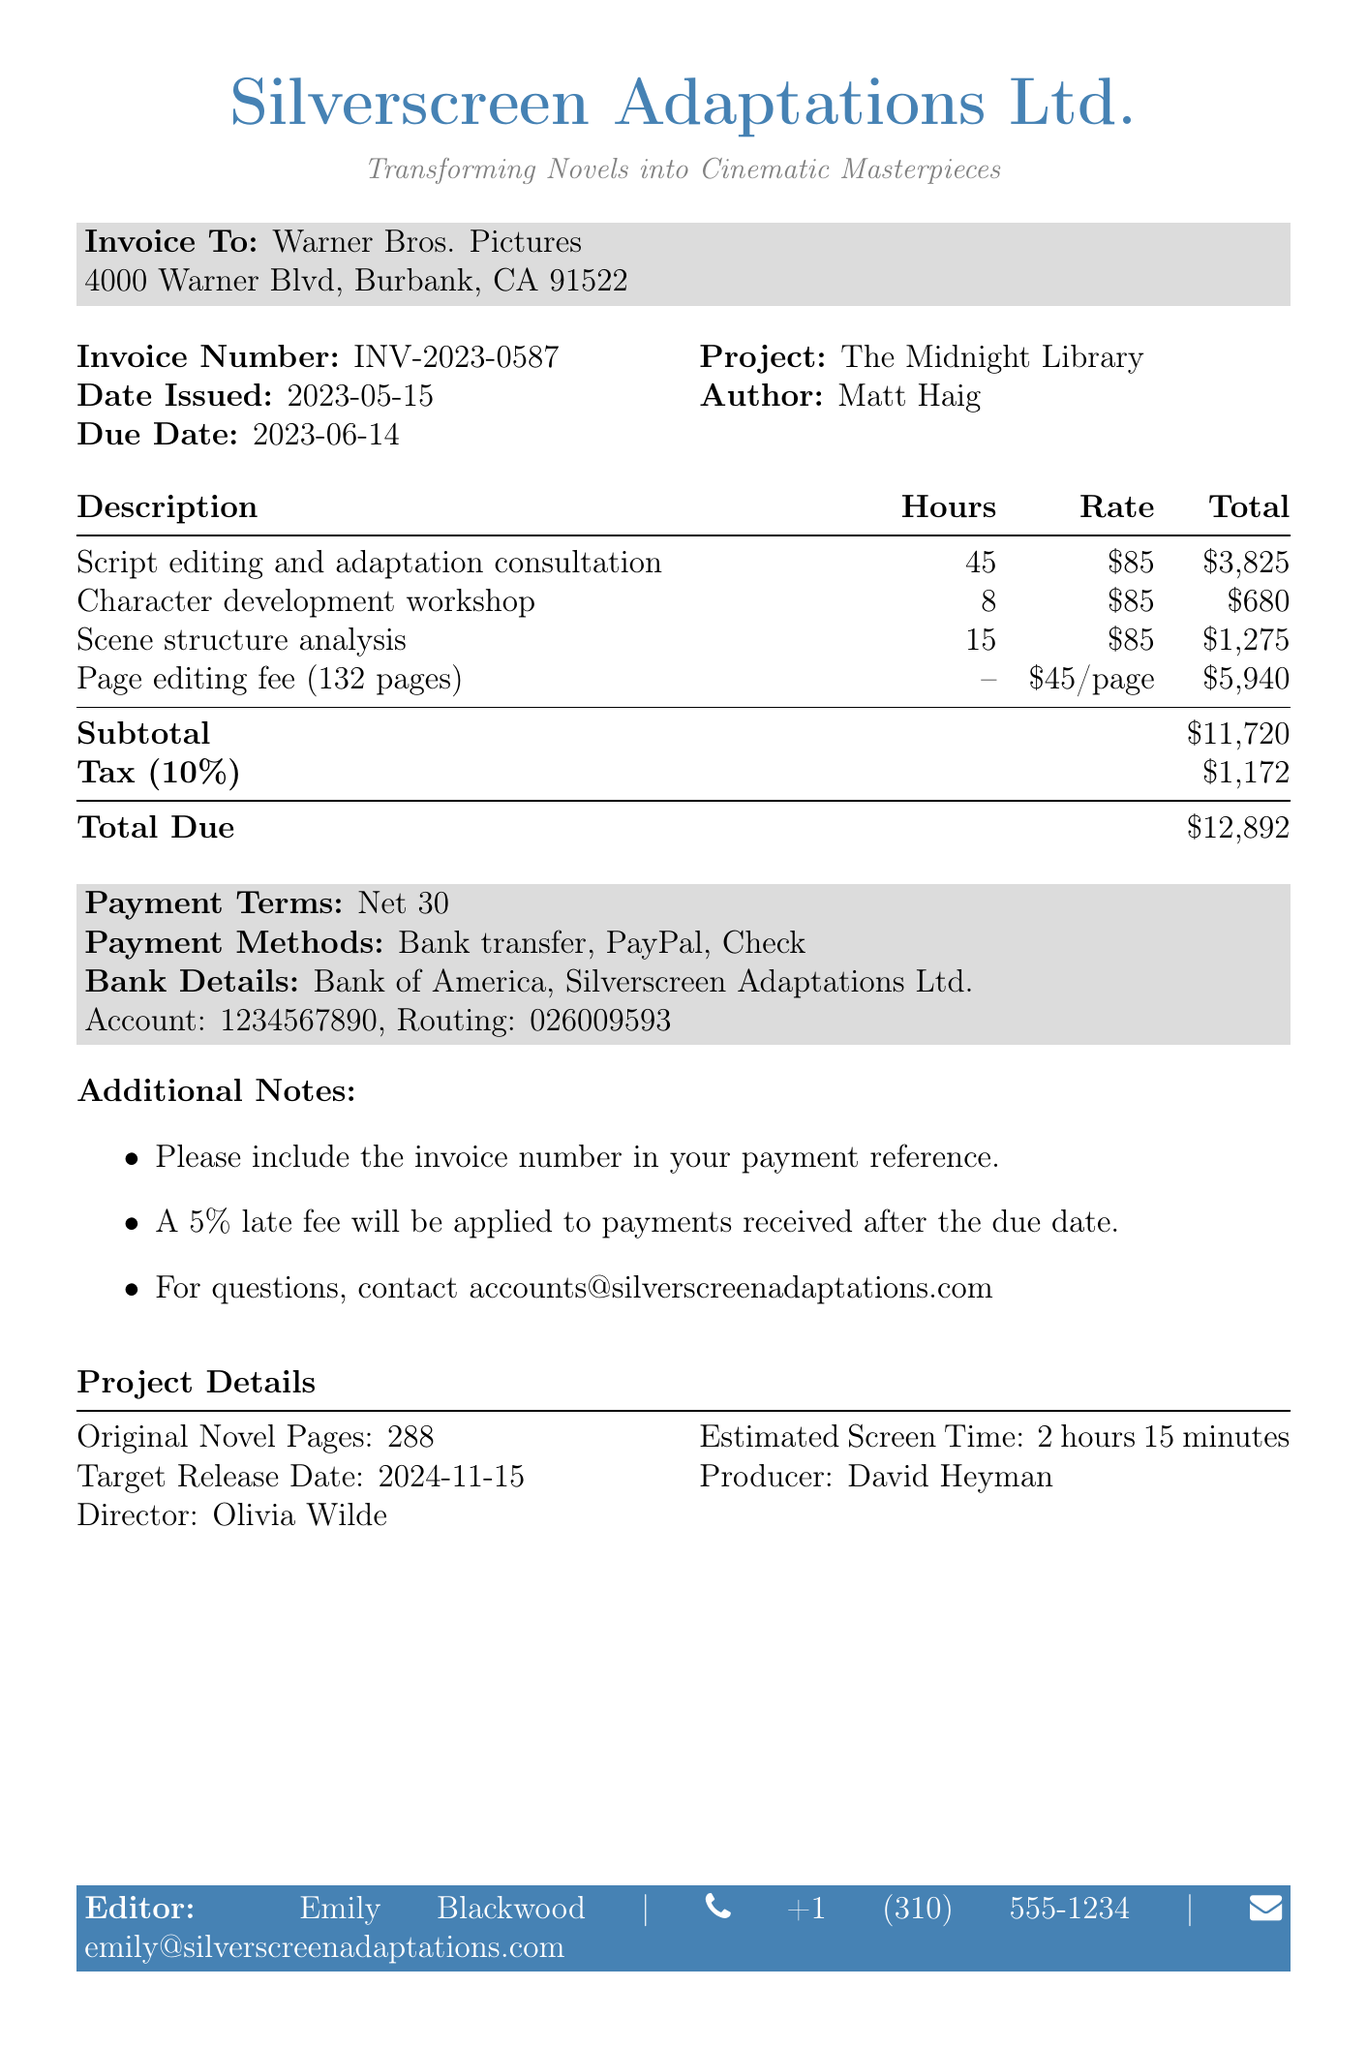What is the invoice number? The invoice number is explicitly stated in the document under the invoice details section as INV-2023-0587.
Answer: INV-2023-0587 Who is the editor? The editor's name is listed in the document under the editor details section.
Answer: Emily Blackwood What is the due date of the invoice? The due date is mentioned in the document as a specific date for payment.
Answer: 2023-06-14 How many script pages were edited? The number of script pages is specified in the project title section of the document.
Answer: 132 What is the subtotal before tax? The subtotal is the sum of all services rendered before tax, given in the totals section of the document.
Answer: 11720 How many hours were worked for scene structure analysis? The hours worked for each specific service are detailed in the service section of the document, listing hours per service.
Answer: 15 What is the total amount due? The total due is the final amount that the client needs to pay, provided in the totals section of the document.
Answer: 12892 What is the hourly rate for editing services? The hourly rate is specified in the services section for editing services.
Answer: 85 How many years of experience does the editor have? The editor's qualifications section mentions the number of years of experience the editor possesses.
Answer: 10+ years 